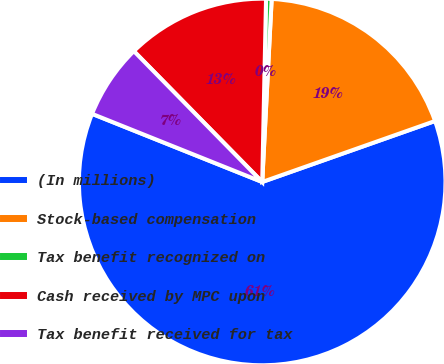<chart> <loc_0><loc_0><loc_500><loc_500><pie_chart><fcel>(In millions)<fcel>Stock-based compensation<fcel>Tax benefit recognized on<fcel>Cash received by MPC upon<fcel>Tax benefit received for tax<nl><fcel>61.46%<fcel>18.78%<fcel>0.49%<fcel>12.68%<fcel>6.59%<nl></chart> 